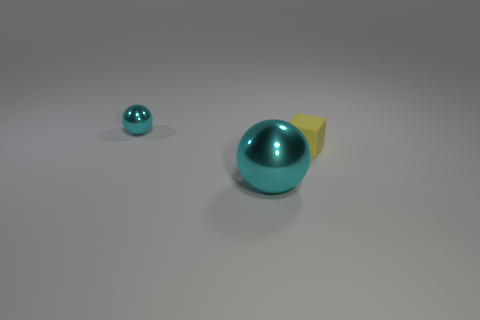Add 2 large gray matte objects. How many objects exist? 5 Subtract 0 red cylinders. How many objects are left? 3 Subtract all cubes. How many objects are left? 2 Subtract all small gray metal cylinders. Subtract all small cyan spheres. How many objects are left? 2 Add 3 tiny metallic things. How many tiny metallic things are left? 4 Add 1 small brown matte cubes. How many small brown matte cubes exist? 1 